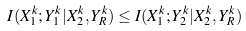Convert formula to latex. <formula><loc_0><loc_0><loc_500><loc_500>I ( X _ { 1 } ^ { k } ; Y _ { 1 } ^ { k } | X _ { 2 } ^ { k } , Y _ { R } ^ { k } ) & \leq I ( X _ { 1 } ^ { k } ; Y _ { 2 } ^ { k } | X _ { 2 } ^ { k } , Y _ { R } ^ { k } )</formula> 